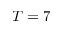<formula> <loc_0><loc_0><loc_500><loc_500>T = 7</formula> 